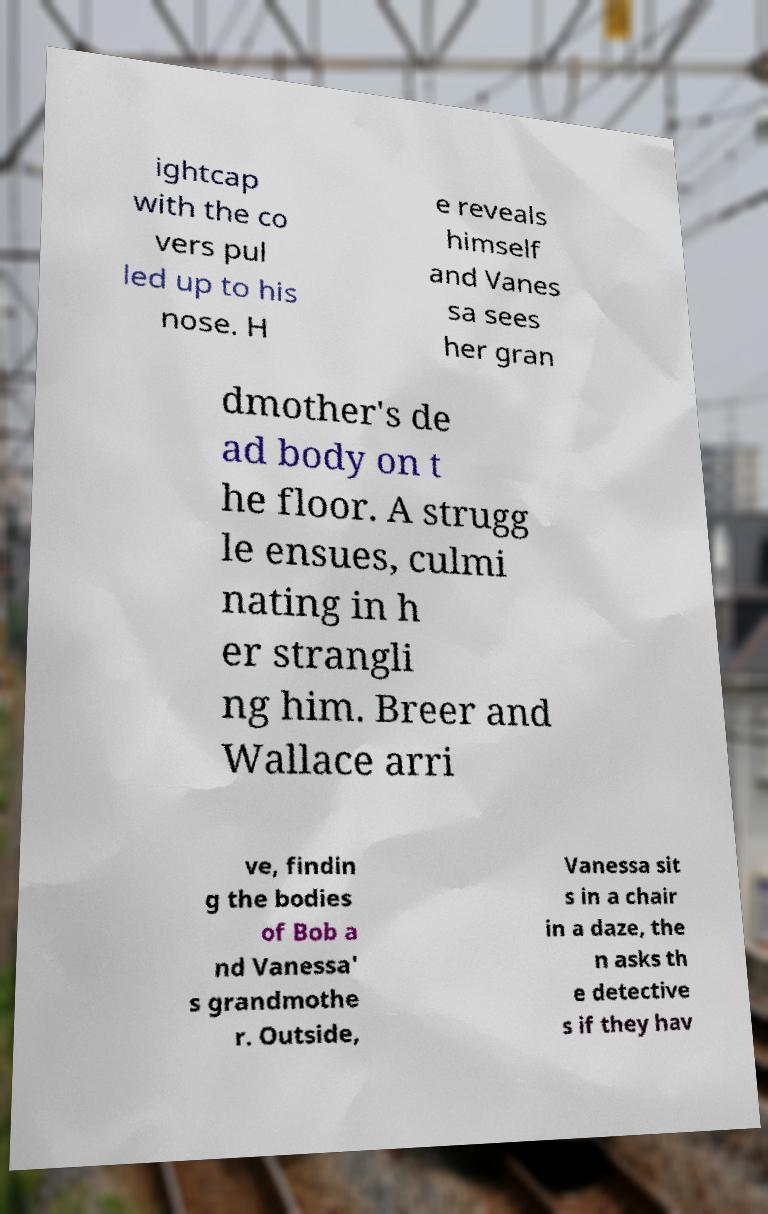Please identify and transcribe the text found in this image. ightcap with the co vers pul led up to his nose. H e reveals himself and Vanes sa sees her gran dmother's de ad body on t he floor. A strugg le ensues, culmi nating in h er strangli ng him. Breer and Wallace arri ve, findin g the bodies of Bob a nd Vanessa' s grandmothe r. Outside, Vanessa sit s in a chair in a daze, the n asks th e detective s if they hav 